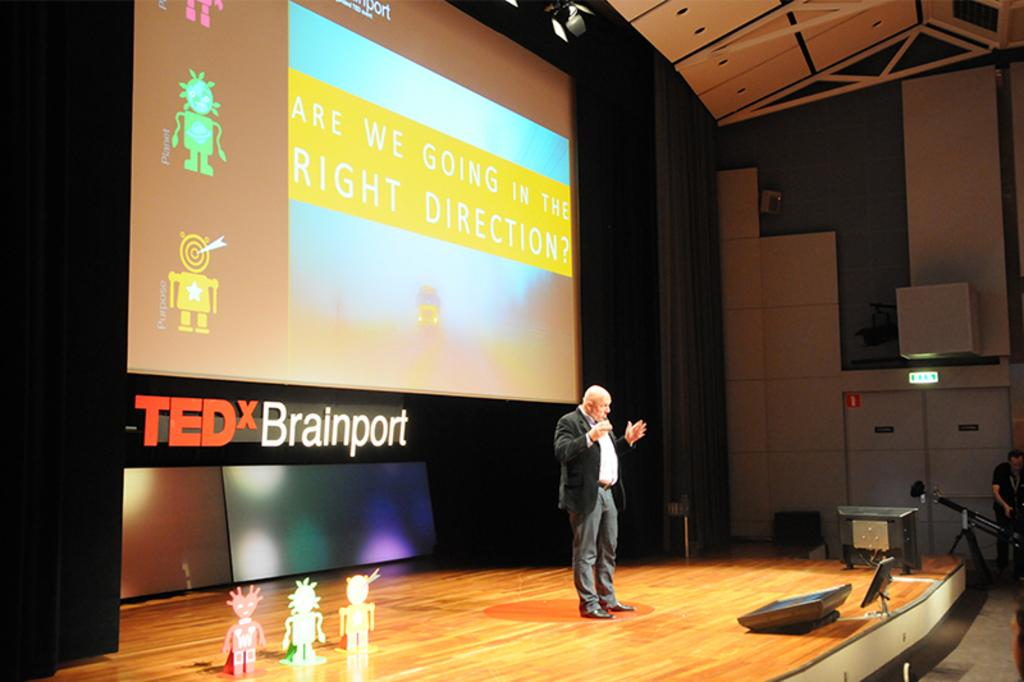<image>
Render a clear and concise summary of the photo. A man standing on a state speaking to an audience at Tedx brainport. 